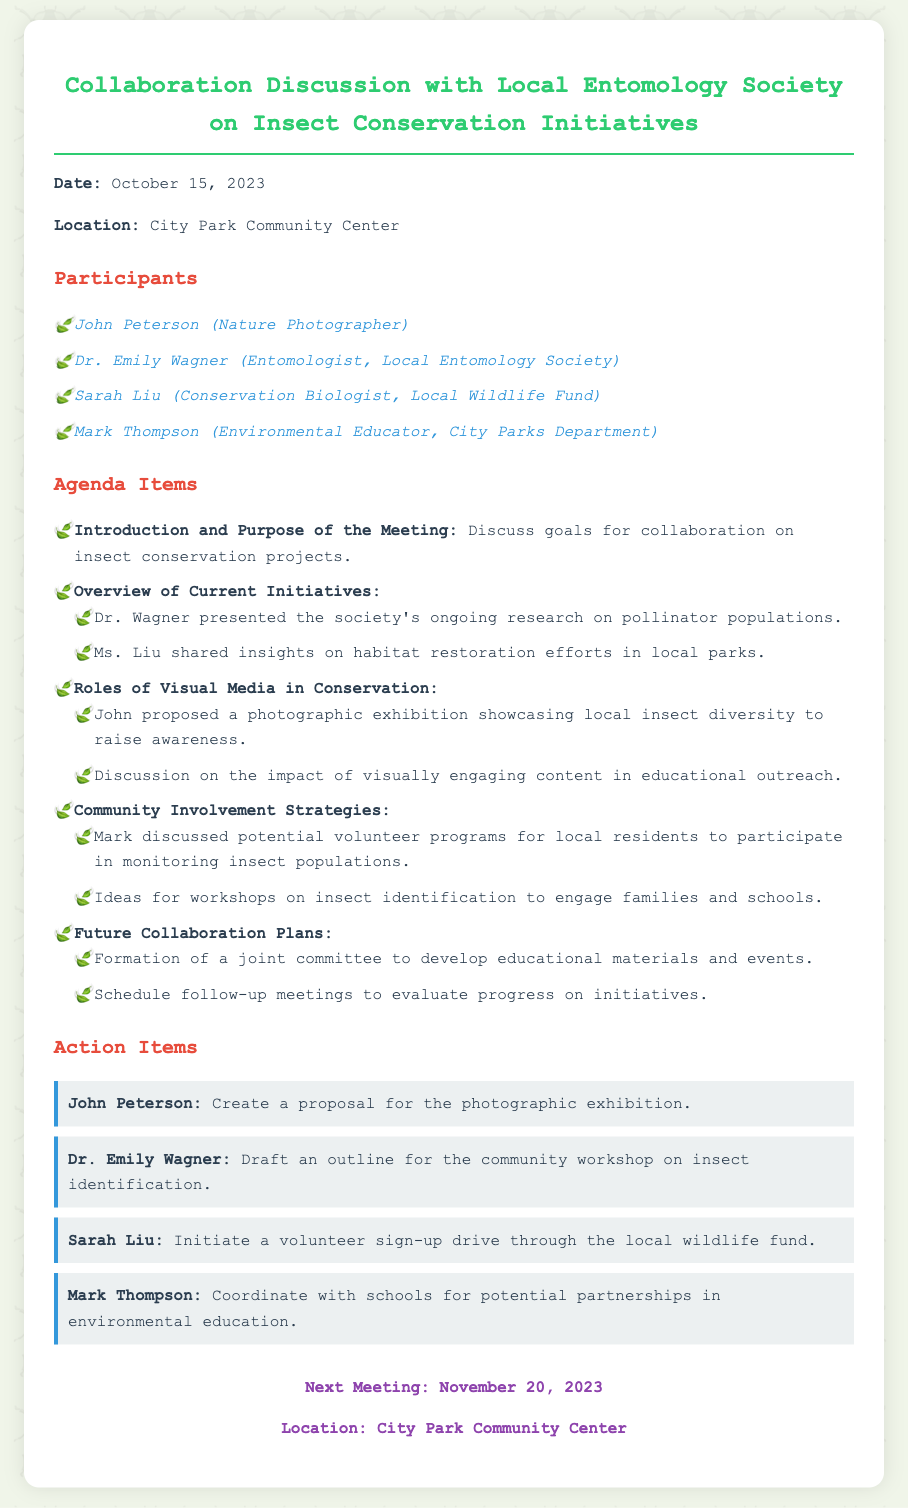What is the date of the meeting? The date of the meeting is specified in the document's introduction section.
Answer: October 15, 2023 Who is the entomologist present at the meeting? The document lists participants, and one is identified as an entomologist.
Answer: Dr. Emily Wagner What was proposed by John during the meeting? The document outlines John's proposal in the agenda item regarding visual media in conservation.
Answer: Photographic exhibition Which organization is Sarah Liu affiliated with? The participants section indicates the organization for Sarah Liu.
Answer: Local Wildlife Fund What is one action item for Dr. Emily Wagner? The action items section specifies what Dr. Emily Wagner is responsible for after the meeting.
Answer: Draft an outline for the community workshop on insect identification What is the purpose of the joint committee mentioned? The document mentions the purpose of the committee in future collaboration plans.
Answer: Develop educational materials and events How many participants were in the meeting? By counting the listed participants, we can determine the total number.
Answer: Four When is the next meeting scheduled? The document provides the date for the next meeting in the last section.
Answer: November 20, 2023 